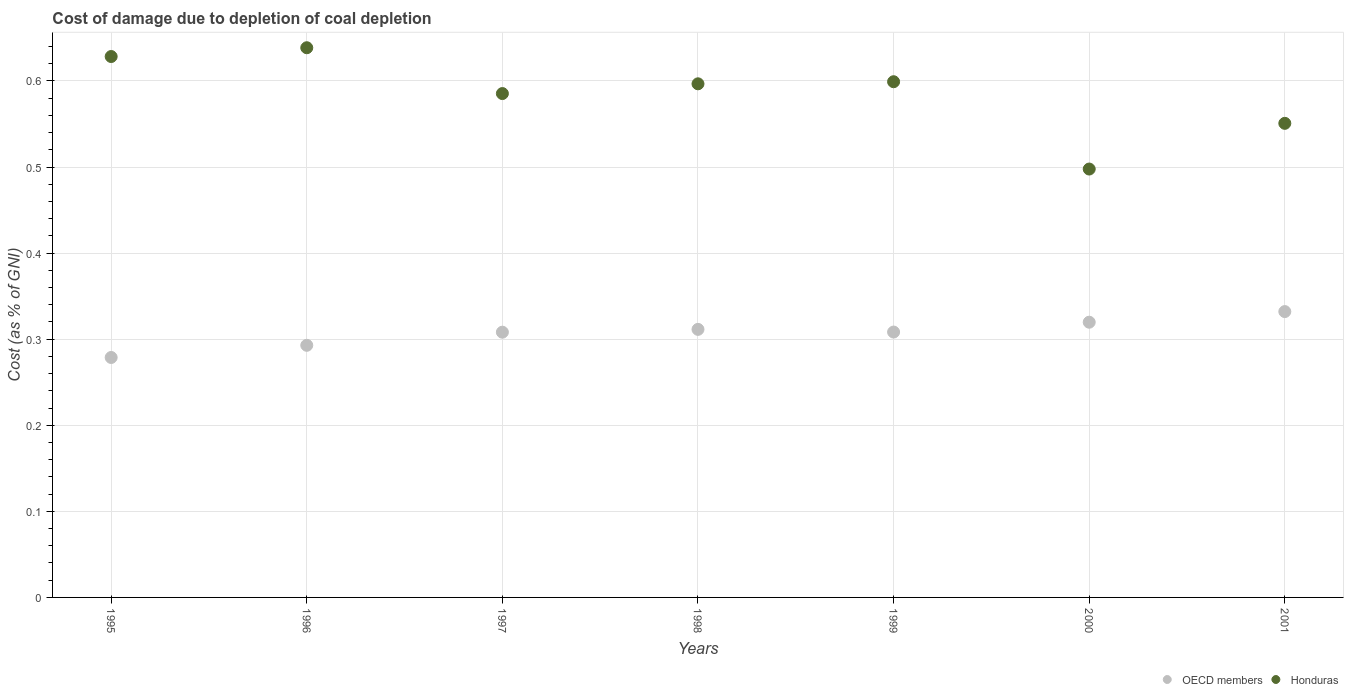Is the number of dotlines equal to the number of legend labels?
Offer a very short reply. Yes. What is the cost of damage caused due to coal depletion in Honduras in 2000?
Your answer should be compact. 0.5. Across all years, what is the maximum cost of damage caused due to coal depletion in OECD members?
Give a very brief answer. 0.33. Across all years, what is the minimum cost of damage caused due to coal depletion in OECD members?
Give a very brief answer. 0.28. What is the total cost of damage caused due to coal depletion in OECD members in the graph?
Your response must be concise. 2.15. What is the difference between the cost of damage caused due to coal depletion in OECD members in 1997 and that in 2001?
Give a very brief answer. -0.02. What is the difference between the cost of damage caused due to coal depletion in OECD members in 1995 and the cost of damage caused due to coal depletion in Honduras in 2001?
Offer a terse response. -0.27. What is the average cost of damage caused due to coal depletion in OECD members per year?
Provide a short and direct response. 0.31. In the year 2000, what is the difference between the cost of damage caused due to coal depletion in OECD members and cost of damage caused due to coal depletion in Honduras?
Offer a terse response. -0.18. In how many years, is the cost of damage caused due to coal depletion in OECD members greater than 0.26 %?
Provide a succinct answer. 7. What is the ratio of the cost of damage caused due to coal depletion in Honduras in 1995 to that in 1998?
Offer a very short reply. 1.05. Is the difference between the cost of damage caused due to coal depletion in OECD members in 1996 and 2000 greater than the difference between the cost of damage caused due to coal depletion in Honduras in 1996 and 2000?
Provide a succinct answer. No. What is the difference between the highest and the second highest cost of damage caused due to coal depletion in OECD members?
Offer a terse response. 0.01. What is the difference between the highest and the lowest cost of damage caused due to coal depletion in Honduras?
Make the answer very short. 0.14. In how many years, is the cost of damage caused due to coal depletion in OECD members greater than the average cost of damage caused due to coal depletion in OECD members taken over all years?
Your answer should be very brief. 5. Does the cost of damage caused due to coal depletion in Honduras monotonically increase over the years?
Keep it short and to the point. No. Is the cost of damage caused due to coal depletion in OECD members strictly less than the cost of damage caused due to coal depletion in Honduras over the years?
Your answer should be very brief. Yes. How many dotlines are there?
Ensure brevity in your answer.  2. What is the difference between two consecutive major ticks on the Y-axis?
Make the answer very short. 0.1. Are the values on the major ticks of Y-axis written in scientific E-notation?
Keep it short and to the point. No. Does the graph contain any zero values?
Your response must be concise. No. Does the graph contain grids?
Your response must be concise. Yes. Where does the legend appear in the graph?
Make the answer very short. Bottom right. How many legend labels are there?
Your answer should be compact. 2. What is the title of the graph?
Ensure brevity in your answer.  Cost of damage due to depletion of coal depletion. Does "Congo (Republic)" appear as one of the legend labels in the graph?
Offer a very short reply. No. What is the label or title of the Y-axis?
Provide a succinct answer. Cost (as % of GNI). What is the Cost (as % of GNI) in OECD members in 1995?
Make the answer very short. 0.28. What is the Cost (as % of GNI) in Honduras in 1995?
Keep it short and to the point. 0.63. What is the Cost (as % of GNI) in OECD members in 1996?
Offer a very short reply. 0.29. What is the Cost (as % of GNI) in Honduras in 1996?
Ensure brevity in your answer.  0.64. What is the Cost (as % of GNI) of OECD members in 1997?
Your answer should be very brief. 0.31. What is the Cost (as % of GNI) of Honduras in 1997?
Keep it short and to the point. 0.59. What is the Cost (as % of GNI) of OECD members in 1998?
Give a very brief answer. 0.31. What is the Cost (as % of GNI) of Honduras in 1998?
Keep it short and to the point. 0.6. What is the Cost (as % of GNI) in OECD members in 1999?
Make the answer very short. 0.31. What is the Cost (as % of GNI) of Honduras in 1999?
Ensure brevity in your answer.  0.6. What is the Cost (as % of GNI) in OECD members in 2000?
Make the answer very short. 0.32. What is the Cost (as % of GNI) of Honduras in 2000?
Your response must be concise. 0.5. What is the Cost (as % of GNI) in OECD members in 2001?
Your answer should be compact. 0.33. What is the Cost (as % of GNI) of Honduras in 2001?
Ensure brevity in your answer.  0.55. Across all years, what is the maximum Cost (as % of GNI) of OECD members?
Ensure brevity in your answer.  0.33. Across all years, what is the maximum Cost (as % of GNI) in Honduras?
Provide a short and direct response. 0.64. Across all years, what is the minimum Cost (as % of GNI) of OECD members?
Give a very brief answer. 0.28. Across all years, what is the minimum Cost (as % of GNI) of Honduras?
Your answer should be very brief. 0.5. What is the total Cost (as % of GNI) of OECD members in the graph?
Your answer should be compact. 2.15. What is the total Cost (as % of GNI) in Honduras in the graph?
Your answer should be very brief. 4.1. What is the difference between the Cost (as % of GNI) in OECD members in 1995 and that in 1996?
Your answer should be compact. -0.01. What is the difference between the Cost (as % of GNI) in Honduras in 1995 and that in 1996?
Make the answer very short. -0.01. What is the difference between the Cost (as % of GNI) of OECD members in 1995 and that in 1997?
Ensure brevity in your answer.  -0.03. What is the difference between the Cost (as % of GNI) of Honduras in 1995 and that in 1997?
Your answer should be very brief. 0.04. What is the difference between the Cost (as % of GNI) of OECD members in 1995 and that in 1998?
Make the answer very short. -0.03. What is the difference between the Cost (as % of GNI) in Honduras in 1995 and that in 1998?
Give a very brief answer. 0.03. What is the difference between the Cost (as % of GNI) of OECD members in 1995 and that in 1999?
Your answer should be very brief. -0.03. What is the difference between the Cost (as % of GNI) in Honduras in 1995 and that in 1999?
Offer a terse response. 0.03. What is the difference between the Cost (as % of GNI) of OECD members in 1995 and that in 2000?
Provide a short and direct response. -0.04. What is the difference between the Cost (as % of GNI) in Honduras in 1995 and that in 2000?
Provide a short and direct response. 0.13. What is the difference between the Cost (as % of GNI) of OECD members in 1995 and that in 2001?
Your answer should be compact. -0.05. What is the difference between the Cost (as % of GNI) in Honduras in 1995 and that in 2001?
Keep it short and to the point. 0.08. What is the difference between the Cost (as % of GNI) of OECD members in 1996 and that in 1997?
Keep it short and to the point. -0.02. What is the difference between the Cost (as % of GNI) of Honduras in 1996 and that in 1997?
Your answer should be very brief. 0.05. What is the difference between the Cost (as % of GNI) in OECD members in 1996 and that in 1998?
Ensure brevity in your answer.  -0.02. What is the difference between the Cost (as % of GNI) of Honduras in 1996 and that in 1998?
Offer a very short reply. 0.04. What is the difference between the Cost (as % of GNI) of OECD members in 1996 and that in 1999?
Give a very brief answer. -0.02. What is the difference between the Cost (as % of GNI) in Honduras in 1996 and that in 1999?
Ensure brevity in your answer.  0.04. What is the difference between the Cost (as % of GNI) in OECD members in 1996 and that in 2000?
Your answer should be very brief. -0.03. What is the difference between the Cost (as % of GNI) of Honduras in 1996 and that in 2000?
Your answer should be compact. 0.14. What is the difference between the Cost (as % of GNI) in OECD members in 1996 and that in 2001?
Provide a succinct answer. -0.04. What is the difference between the Cost (as % of GNI) in Honduras in 1996 and that in 2001?
Provide a short and direct response. 0.09. What is the difference between the Cost (as % of GNI) in OECD members in 1997 and that in 1998?
Provide a succinct answer. -0. What is the difference between the Cost (as % of GNI) in Honduras in 1997 and that in 1998?
Your answer should be compact. -0.01. What is the difference between the Cost (as % of GNI) in OECD members in 1997 and that in 1999?
Give a very brief answer. -0. What is the difference between the Cost (as % of GNI) of Honduras in 1997 and that in 1999?
Offer a very short reply. -0.01. What is the difference between the Cost (as % of GNI) in OECD members in 1997 and that in 2000?
Offer a very short reply. -0.01. What is the difference between the Cost (as % of GNI) in Honduras in 1997 and that in 2000?
Offer a terse response. 0.09. What is the difference between the Cost (as % of GNI) of OECD members in 1997 and that in 2001?
Provide a succinct answer. -0.02. What is the difference between the Cost (as % of GNI) in Honduras in 1997 and that in 2001?
Ensure brevity in your answer.  0.03. What is the difference between the Cost (as % of GNI) of OECD members in 1998 and that in 1999?
Provide a succinct answer. 0. What is the difference between the Cost (as % of GNI) of Honduras in 1998 and that in 1999?
Make the answer very short. -0. What is the difference between the Cost (as % of GNI) in OECD members in 1998 and that in 2000?
Offer a terse response. -0.01. What is the difference between the Cost (as % of GNI) of Honduras in 1998 and that in 2000?
Your response must be concise. 0.1. What is the difference between the Cost (as % of GNI) in OECD members in 1998 and that in 2001?
Provide a short and direct response. -0.02. What is the difference between the Cost (as % of GNI) of Honduras in 1998 and that in 2001?
Your response must be concise. 0.05. What is the difference between the Cost (as % of GNI) in OECD members in 1999 and that in 2000?
Your response must be concise. -0.01. What is the difference between the Cost (as % of GNI) of Honduras in 1999 and that in 2000?
Provide a succinct answer. 0.1. What is the difference between the Cost (as % of GNI) in OECD members in 1999 and that in 2001?
Your answer should be very brief. -0.02. What is the difference between the Cost (as % of GNI) in Honduras in 1999 and that in 2001?
Provide a short and direct response. 0.05. What is the difference between the Cost (as % of GNI) of OECD members in 2000 and that in 2001?
Your response must be concise. -0.01. What is the difference between the Cost (as % of GNI) in Honduras in 2000 and that in 2001?
Your answer should be compact. -0.05. What is the difference between the Cost (as % of GNI) of OECD members in 1995 and the Cost (as % of GNI) of Honduras in 1996?
Offer a very short reply. -0.36. What is the difference between the Cost (as % of GNI) in OECD members in 1995 and the Cost (as % of GNI) in Honduras in 1997?
Provide a short and direct response. -0.31. What is the difference between the Cost (as % of GNI) of OECD members in 1995 and the Cost (as % of GNI) of Honduras in 1998?
Give a very brief answer. -0.32. What is the difference between the Cost (as % of GNI) in OECD members in 1995 and the Cost (as % of GNI) in Honduras in 1999?
Offer a very short reply. -0.32. What is the difference between the Cost (as % of GNI) of OECD members in 1995 and the Cost (as % of GNI) of Honduras in 2000?
Offer a terse response. -0.22. What is the difference between the Cost (as % of GNI) in OECD members in 1995 and the Cost (as % of GNI) in Honduras in 2001?
Keep it short and to the point. -0.27. What is the difference between the Cost (as % of GNI) in OECD members in 1996 and the Cost (as % of GNI) in Honduras in 1997?
Provide a short and direct response. -0.29. What is the difference between the Cost (as % of GNI) of OECD members in 1996 and the Cost (as % of GNI) of Honduras in 1998?
Provide a succinct answer. -0.3. What is the difference between the Cost (as % of GNI) in OECD members in 1996 and the Cost (as % of GNI) in Honduras in 1999?
Your answer should be very brief. -0.31. What is the difference between the Cost (as % of GNI) of OECD members in 1996 and the Cost (as % of GNI) of Honduras in 2000?
Your response must be concise. -0.2. What is the difference between the Cost (as % of GNI) in OECD members in 1996 and the Cost (as % of GNI) in Honduras in 2001?
Give a very brief answer. -0.26. What is the difference between the Cost (as % of GNI) of OECD members in 1997 and the Cost (as % of GNI) of Honduras in 1998?
Make the answer very short. -0.29. What is the difference between the Cost (as % of GNI) in OECD members in 1997 and the Cost (as % of GNI) in Honduras in 1999?
Offer a terse response. -0.29. What is the difference between the Cost (as % of GNI) of OECD members in 1997 and the Cost (as % of GNI) of Honduras in 2000?
Ensure brevity in your answer.  -0.19. What is the difference between the Cost (as % of GNI) of OECD members in 1997 and the Cost (as % of GNI) of Honduras in 2001?
Make the answer very short. -0.24. What is the difference between the Cost (as % of GNI) of OECD members in 1998 and the Cost (as % of GNI) of Honduras in 1999?
Ensure brevity in your answer.  -0.29. What is the difference between the Cost (as % of GNI) of OECD members in 1998 and the Cost (as % of GNI) of Honduras in 2000?
Offer a terse response. -0.19. What is the difference between the Cost (as % of GNI) in OECD members in 1998 and the Cost (as % of GNI) in Honduras in 2001?
Make the answer very short. -0.24. What is the difference between the Cost (as % of GNI) in OECD members in 1999 and the Cost (as % of GNI) in Honduras in 2000?
Ensure brevity in your answer.  -0.19. What is the difference between the Cost (as % of GNI) of OECD members in 1999 and the Cost (as % of GNI) of Honduras in 2001?
Provide a succinct answer. -0.24. What is the difference between the Cost (as % of GNI) of OECD members in 2000 and the Cost (as % of GNI) of Honduras in 2001?
Keep it short and to the point. -0.23. What is the average Cost (as % of GNI) of OECD members per year?
Your answer should be very brief. 0.31. What is the average Cost (as % of GNI) in Honduras per year?
Offer a terse response. 0.59. In the year 1995, what is the difference between the Cost (as % of GNI) of OECD members and Cost (as % of GNI) of Honduras?
Your answer should be very brief. -0.35. In the year 1996, what is the difference between the Cost (as % of GNI) of OECD members and Cost (as % of GNI) of Honduras?
Your answer should be very brief. -0.35. In the year 1997, what is the difference between the Cost (as % of GNI) in OECD members and Cost (as % of GNI) in Honduras?
Offer a terse response. -0.28. In the year 1998, what is the difference between the Cost (as % of GNI) of OECD members and Cost (as % of GNI) of Honduras?
Provide a succinct answer. -0.29. In the year 1999, what is the difference between the Cost (as % of GNI) of OECD members and Cost (as % of GNI) of Honduras?
Offer a terse response. -0.29. In the year 2000, what is the difference between the Cost (as % of GNI) in OECD members and Cost (as % of GNI) in Honduras?
Your answer should be very brief. -0.18. In the year 2001, what is the difference between the Cost (as % of GNI) in OECD members and Cost (as % of GNI) in Honduras?
Your response must be concise. -0.22. What is the ratio of the Cost (as % of GNI) of OECD members in 1995 to that in 1996?
Give a very brief answer. 0.95. What is the ratio of the Cost (as % of GNI) of OECD members in 1995 to that in 1997?
Your response must be concise. 0.9. What is the ratio of the Cost (as % of GNI) of Honduras in 1995 to that in 1997?
Your answer should be very brief. 1.07. What is the ratio of the Cost (as % of GNI) of OECD members in 1995 to that in 1998?
Provide a succinct answer. 0.9. What is the ratio of the Cost (as % of GNI) in Honduras in 1995 to that in 1998?
Your answer should be compact. 1.05. What is the ratio of the Cost (as % of GNI) in OECD members in 1995 to that in 1999?
Your answer should be very brief. 0.9. What is the ratio of the Cost (as % of GNI) of Honduras in 1995 to that in 1999?
Your answer should be compact. 1.05. What is the ratio of the Cost (as % of GNI) in OECD members in 1995 to that in 2000?
Your answer should be compact. 0.87. What is the ratio of the Cost (as % of GNI) of Honduras in 1995 to that in 2000?
Provide a short and direct response. 1.26. What is the ratio of the Cost (as % of GNI) in OECD members in 1995 to that in 2001?
Give a very brief answer. 0.84. What is the ratio of the Cost (as % of GNI) in Honduras in 1995 to that in 2001?
Your answer should be compact. 1.14. What is the ratio of the Cost (as % of GNI) of OECD members in 1996 to that in 1997?
Provide a succinct answer. 0.95. What is the ratio of the Cost (as % of GNI) of Honduras in 1996 to that in 1997?
Give a very brief answer. 1.09. What is the ratio of the Cost (as % of GNI) in OECD members in 1996 to that in 1998?
Provide a short and direct response. 0.94. What is the ratio of the Cost (as % of GNI) in Honduras in 1996 to that in 1998?
Keep it short and to the point. 1.07. What is the ratio of the Cost (as % of GNI) of Honduras in 1996 to that in 1999?
Your answer should be very brief. 1.07. What is the ratio of the Cost (as % of GNI) of OECD members in 1996 to that in 2000?
Provide a short and direct response. 0.92. What is the ratio of the Cost (as % of GNI) in Honduras in 1996 to that in 2000?
Make the answer very short. 1.28. What is the ratio of the Cost (as % of GNI) of OECD members in 1996 to that in 2001?
Give a very brief answer. 0.88. What is the ratio of the Cost (as % of GNI) of Honduras in 1996 to that in 2001?
Offer a very short reply. 1.16. What is the ratio of the Cost (as % of GNI) of OECD members in 1997 to that in 2000?
Make the answer very short. 0.96. What is the ratio of the Cost (as % of GNI) of Honduras in 1997 to that in 2000?
Give a very brief answer. 1.18. What is the ratio of the Cost (as % of GNI) of OECD members in 1997 to that in 2001?
Your answer should be compact. 0.93. What is the ratio of the Cost (as % of GNI) of Honduras in 1997 to that in 2001?
Provide a succinct answer. 1.06. What is the ratio of the Cost (as % of GNI) in OECD members in 1998 to that in 1999?
Keep it short and to the point. 1.01. What is the ratio of the Cost (as % of GNI) in Honduras in 1998 to that in 2000?
Provide a short and direct response. 1.2. What is the ratio of the Cost (as % of GNI) in OECD members in 1998 to that in 2001?
Your answer should be very brief. 0.94. What is the ratio of the Cost (as % of GNI) of Honduras in 1998 to that in 2001?
Ensure brevity in your answer.  1.08. What is the ratio of the Cost (as % of GNI) of OECD members in 1999 to that in 2000?
Offer a terse response. 0.96. What is the ratio of the Cost (as % of GNI) in Honduras in 1999 to that in 2000?
Provide a succinct answer. 1.2. What is the ratio of the Cost (as % of GNI) of OECD members in 1999 to that in 2001?
Offer a terse response. 0.93. What is the ratio of the Cost (as % of GNI) in Honduras in 1999 to that in 2001?
Offer a terse response. 1.09. What is the ratio of the Cost (as % of GNI) in OECD members in 2000 to that in 2001?
Offer a terse response. 0.96. What is the ratio of the Cost (as % of GNI) of Honduras in 2000 to that in 2001?
Ensure brevity in your answer.  0.9. What is the difference between the highest and the second highest Cost (as % of GNI) in OECD members?
Offer a terse response. 0.01. What is the difference between the highest and the second highest Cost (as % of GNI) in Honduras?
Give a very brief answer. 0.01. What is the difference between the highest and the lowest Cost (as % of GNI) of OECD members?
Your answer should be compact. 0.05. What is the difference between the highest and the lowest Cost (as % of GNI) of Honduras?
Provide a succinct answer. 0.14. 